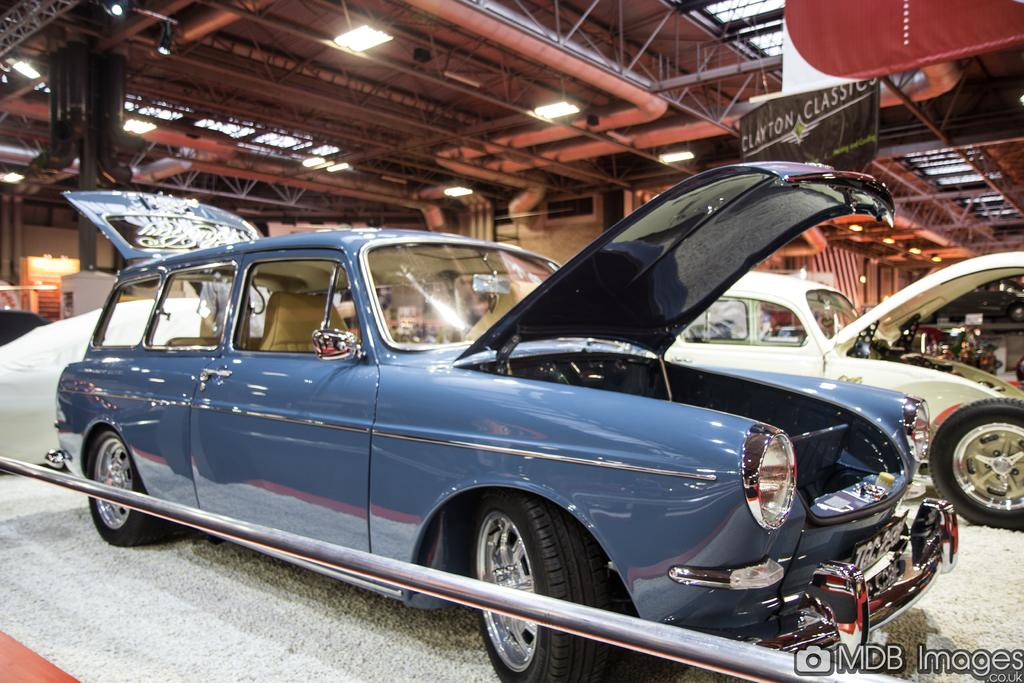What is placed on the floor in the image? There are cars on a carpet on the floor. What can be seen in the background of the image? In the background of the image, there are poles, pipes, a banner, lights, a wall, and other unspecified items. Can you tell me how many dogs are walking on the carpet in the image? There are no dogs present in the image; it features cars on a carpet on the floor. What sense is being stimulated by the items in the image? The image does not provide information about which sense is being stimulated by the items in the image. 